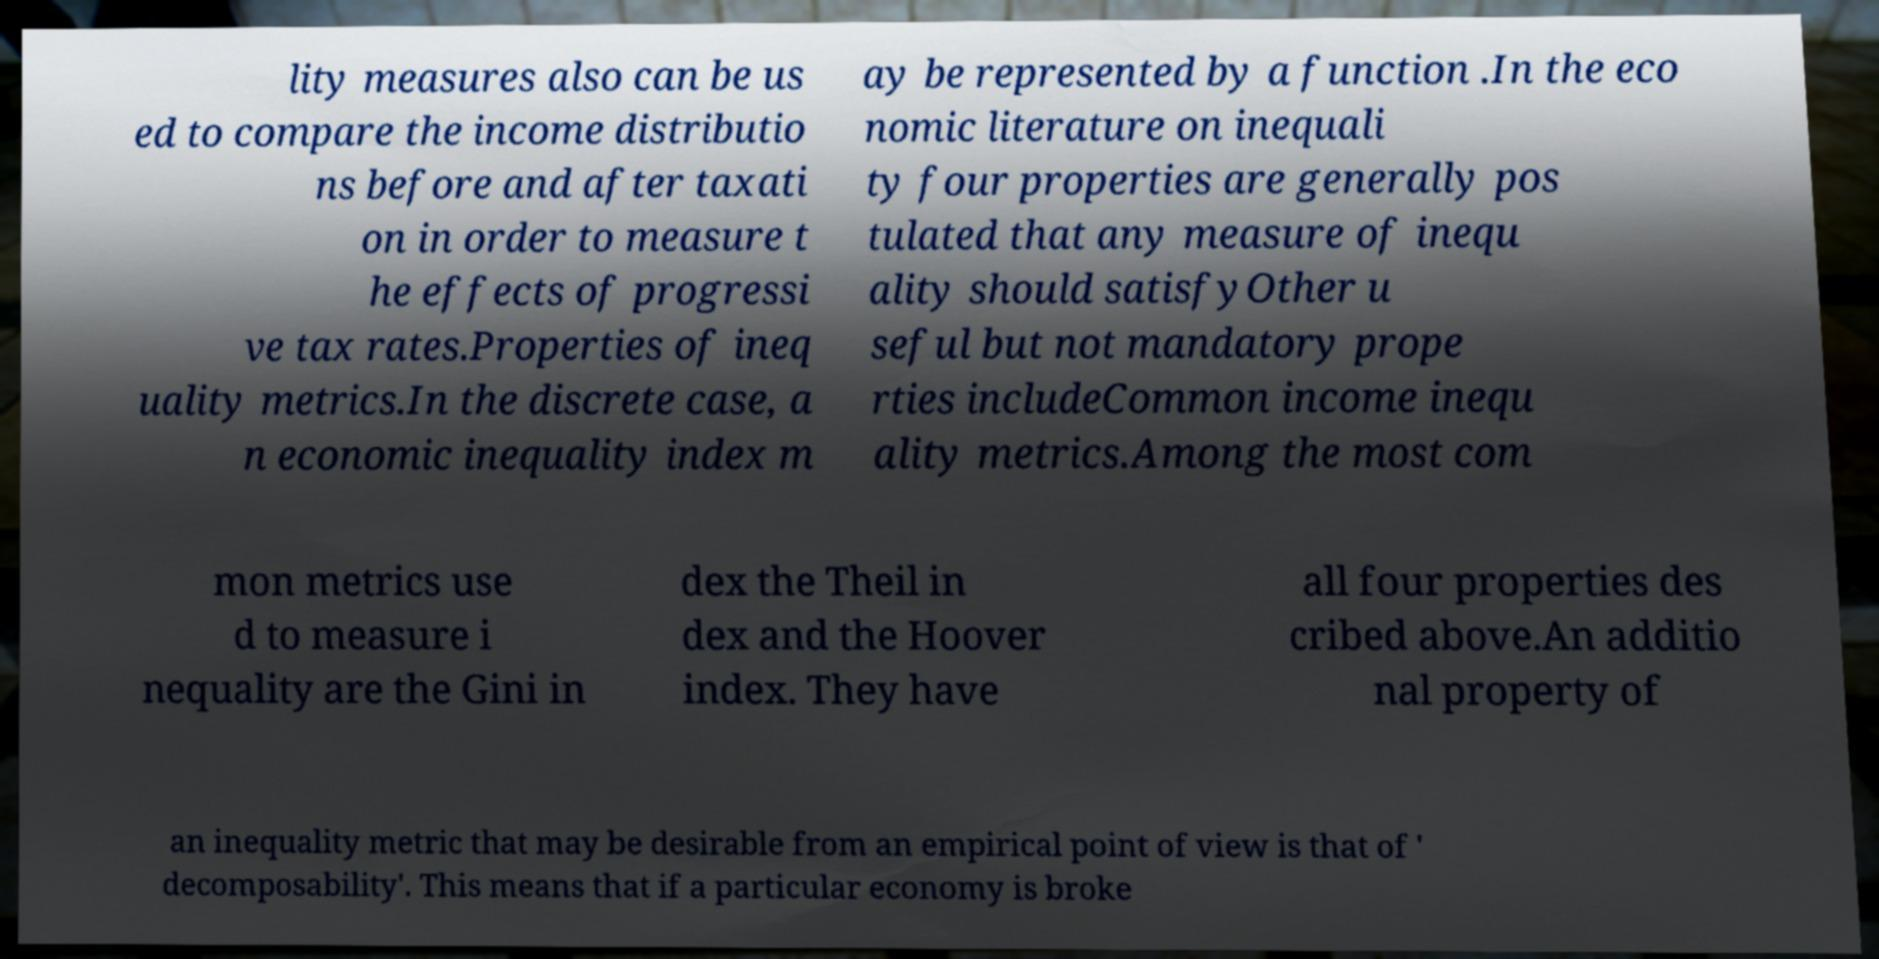What messages or text are displayed in this image? I need them in a readable, typed format. lity measures also can be us ed to compare the income distributio ns before and after taxati on in order to measure t he effects of progressi ve tax rates.Properties of ineq uality metrics.In the discrete case, a n economic inequality index m ay be represented by a function .In the eco nomic literature on inequali ty four properties are generally pos tulated that any measure of inequ ality should satisfyOther u seful but not mandatory prope rties includeCommon income inequ ality metrics.Among the most com mon metrics use d to measure i nequality are the Gini in dex the Theil in dex and the Hoover index. They have all four properties des cribed above.An additio nal property of an inequality metric that may be desirable from an empirical point of view is that of ' decomposability'. This means that if a particular economy is broke 